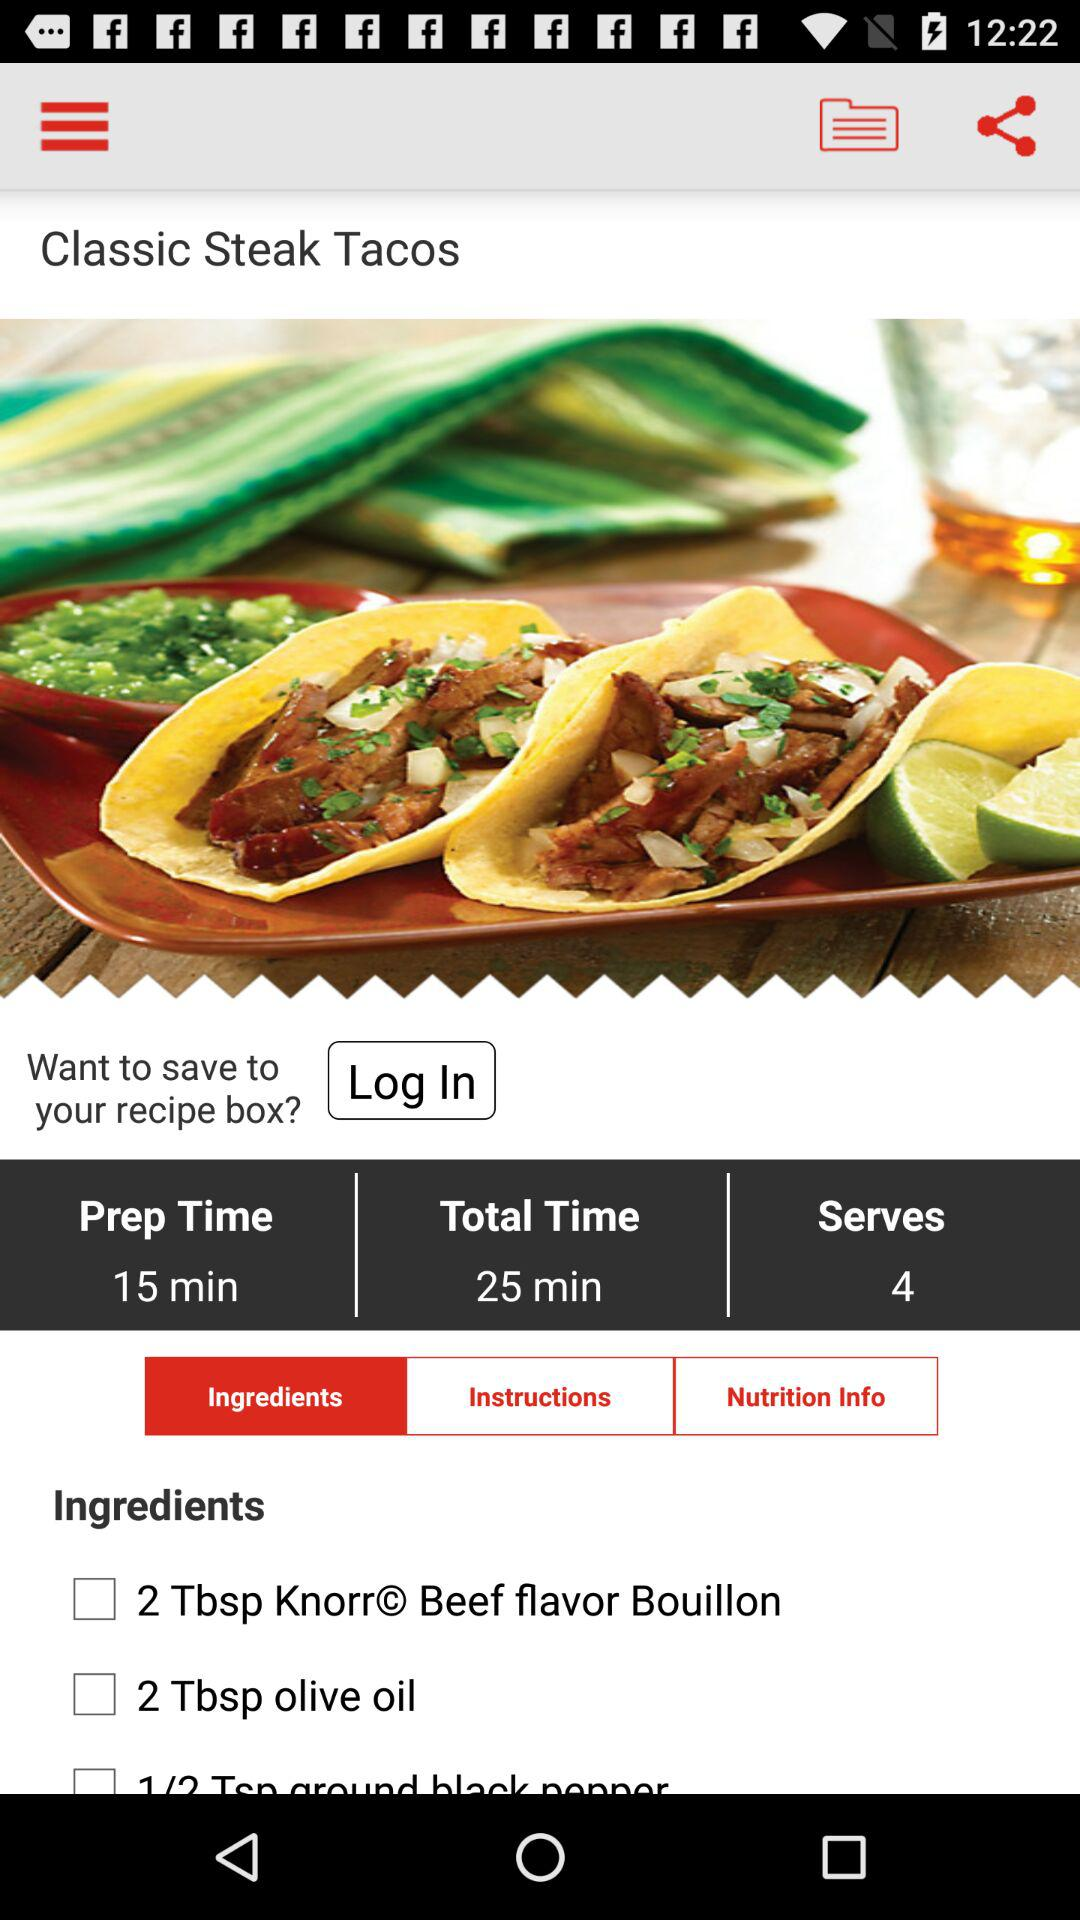What is the total time taken to deliver the food? The total time taken to deliver the food is 25 minutes. 